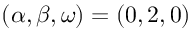Convert formula to latex. <formula><loc_0><loc_0><loc_500><loc_500>( \alpha , \beta , \omega ) = ( 0 , 2 , 0 )</formula> 